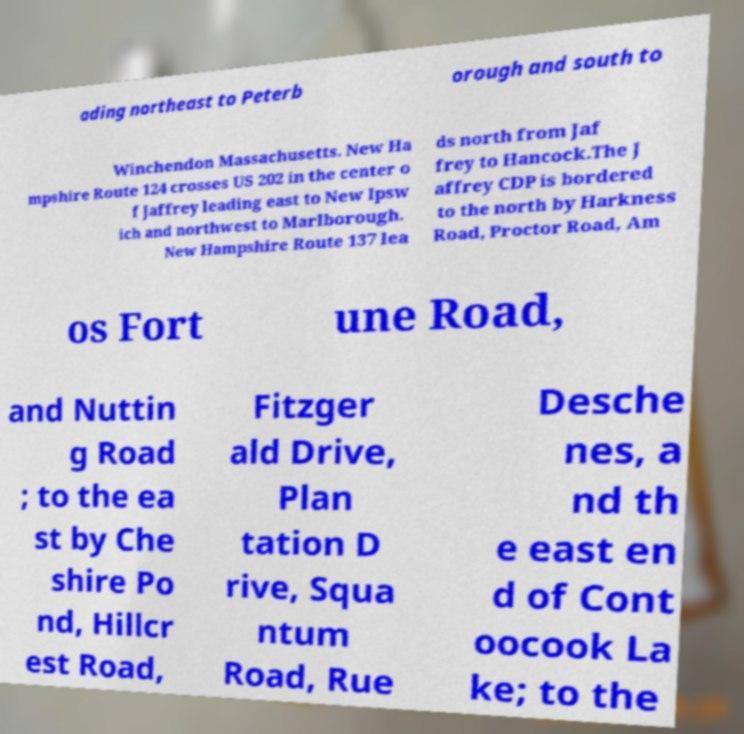What messages or text are displayed in this image? I need them in a readable, typed format. ading northeast to Peterb orough and south to Winchendon Massachusetts. New Ha mpshire Route 124 crosses US 202 in the center o f Jaffrey leading east to New Ipsw ich and northwest to Marlborough. New Hampshire Route 137 lea ds north from Jaf frey to Hancock.The J affrey CDP is bordered to the north by Harkness Road, Proctor Road, Am os Fort une Road, and Nuttin g Road ; to the ea st by Che shire Po nd, Hillcr est Road, Fitzger ald Drive, Plan tation D rive, Squa ntum Road, Rue Desche nes, a nd th e east en d of Cont oocook La ke; to the 